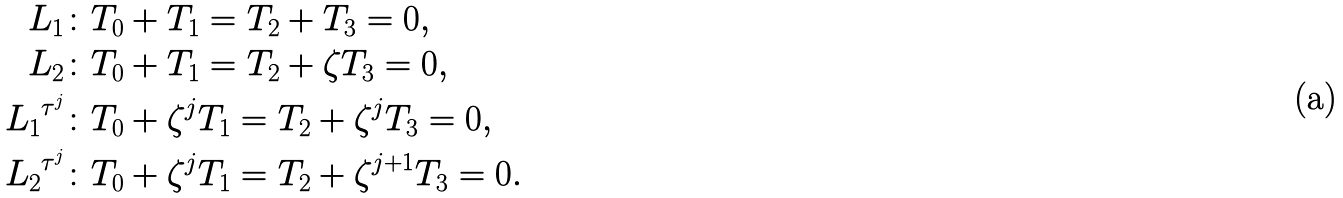Convert formula to latex. <formula><loc_0><loc_0><loc_500><loc_500>L _ { 1 } & \colon T _ { 0 } + T _ { 1 } = T _ { 2 } + T _ { 3 } = 0 , \\ L _ { 2 } & \colon T _ { 0 } + T _ { 1 } = T _ { 2 } + \zeta T _ { 3 } = 0 , \\ { L _ { 1 } } ^ { { \tau } ^ { j } } & \colon T _ { 0 } + { \zeta } ^ { j } T _ { 1 } = T _ { 2 } + { \zeta } ^ { j } T _ { 3 } = 0 , \\ { L _ { 2 } } ^ { { \tau } ^ { j } } & \colon T _ { 0 } + { \zeta } ^ { j } T _ { 1 } = T _ { 2 } + { \zeta } ^ { j + 1 } T _ { 3 } = 0 .</formula> 